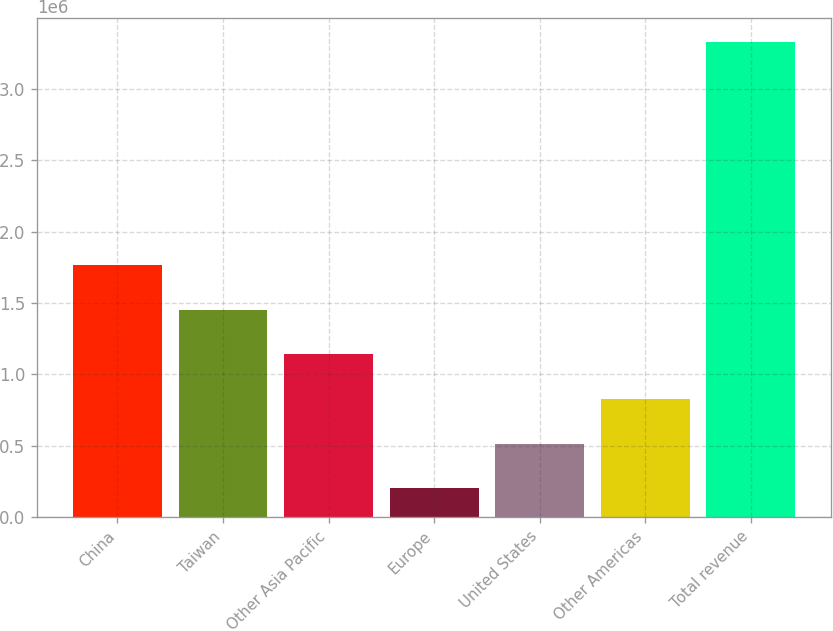Convert chart to OTSL. <chart><loc_0><loc_0><loc_500><loc_500><bar_chart><fcel>China<fcel>Taiwan<fcel>Other Asia Pacific<fcel>Europe<fcel>United States<fcel>Other Americas<fcel>Total revenue<nl><fcel>1.7651e+06<fcel>1.45283e+06<fcel>1.14057e+06<fcel>203760<fcel>516028<fcel>828297<fcel>3.32644e+06<nl></chart> 